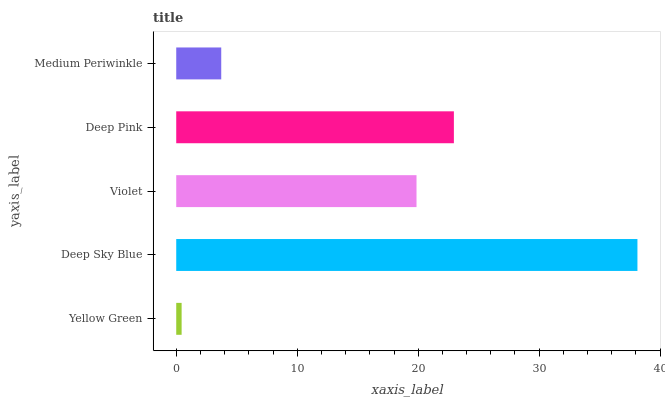Is Yellow Green the minimum?
Answer yes or no. Yes. Is Deep Sky Blue the maximum?
Answer yes or no. Yes. Is Violet the minimum?
Answer yes or no. No. Is Violet the maximum?
Answer yes or no. No. Is Deep Sky Blue greater than Violet?
Answer yes or no. Yes. Is Violet less than Deep Sky Blue?
Answer yes or no. Yes. Is Violet greater than Deep Sky Blue?
Answer yes or no. No. Is Deep Sky Blue less than Violet?
Answer yes or no. No. Is Violet the high median?
Answer yes or no. Yes. Is Violet the low median?
Answer yes or no. Yes. Is Deep Pink the high median?
Answer yes or no. No. Is Medium Periwinkle the low median?
Answer yes or no. No. 